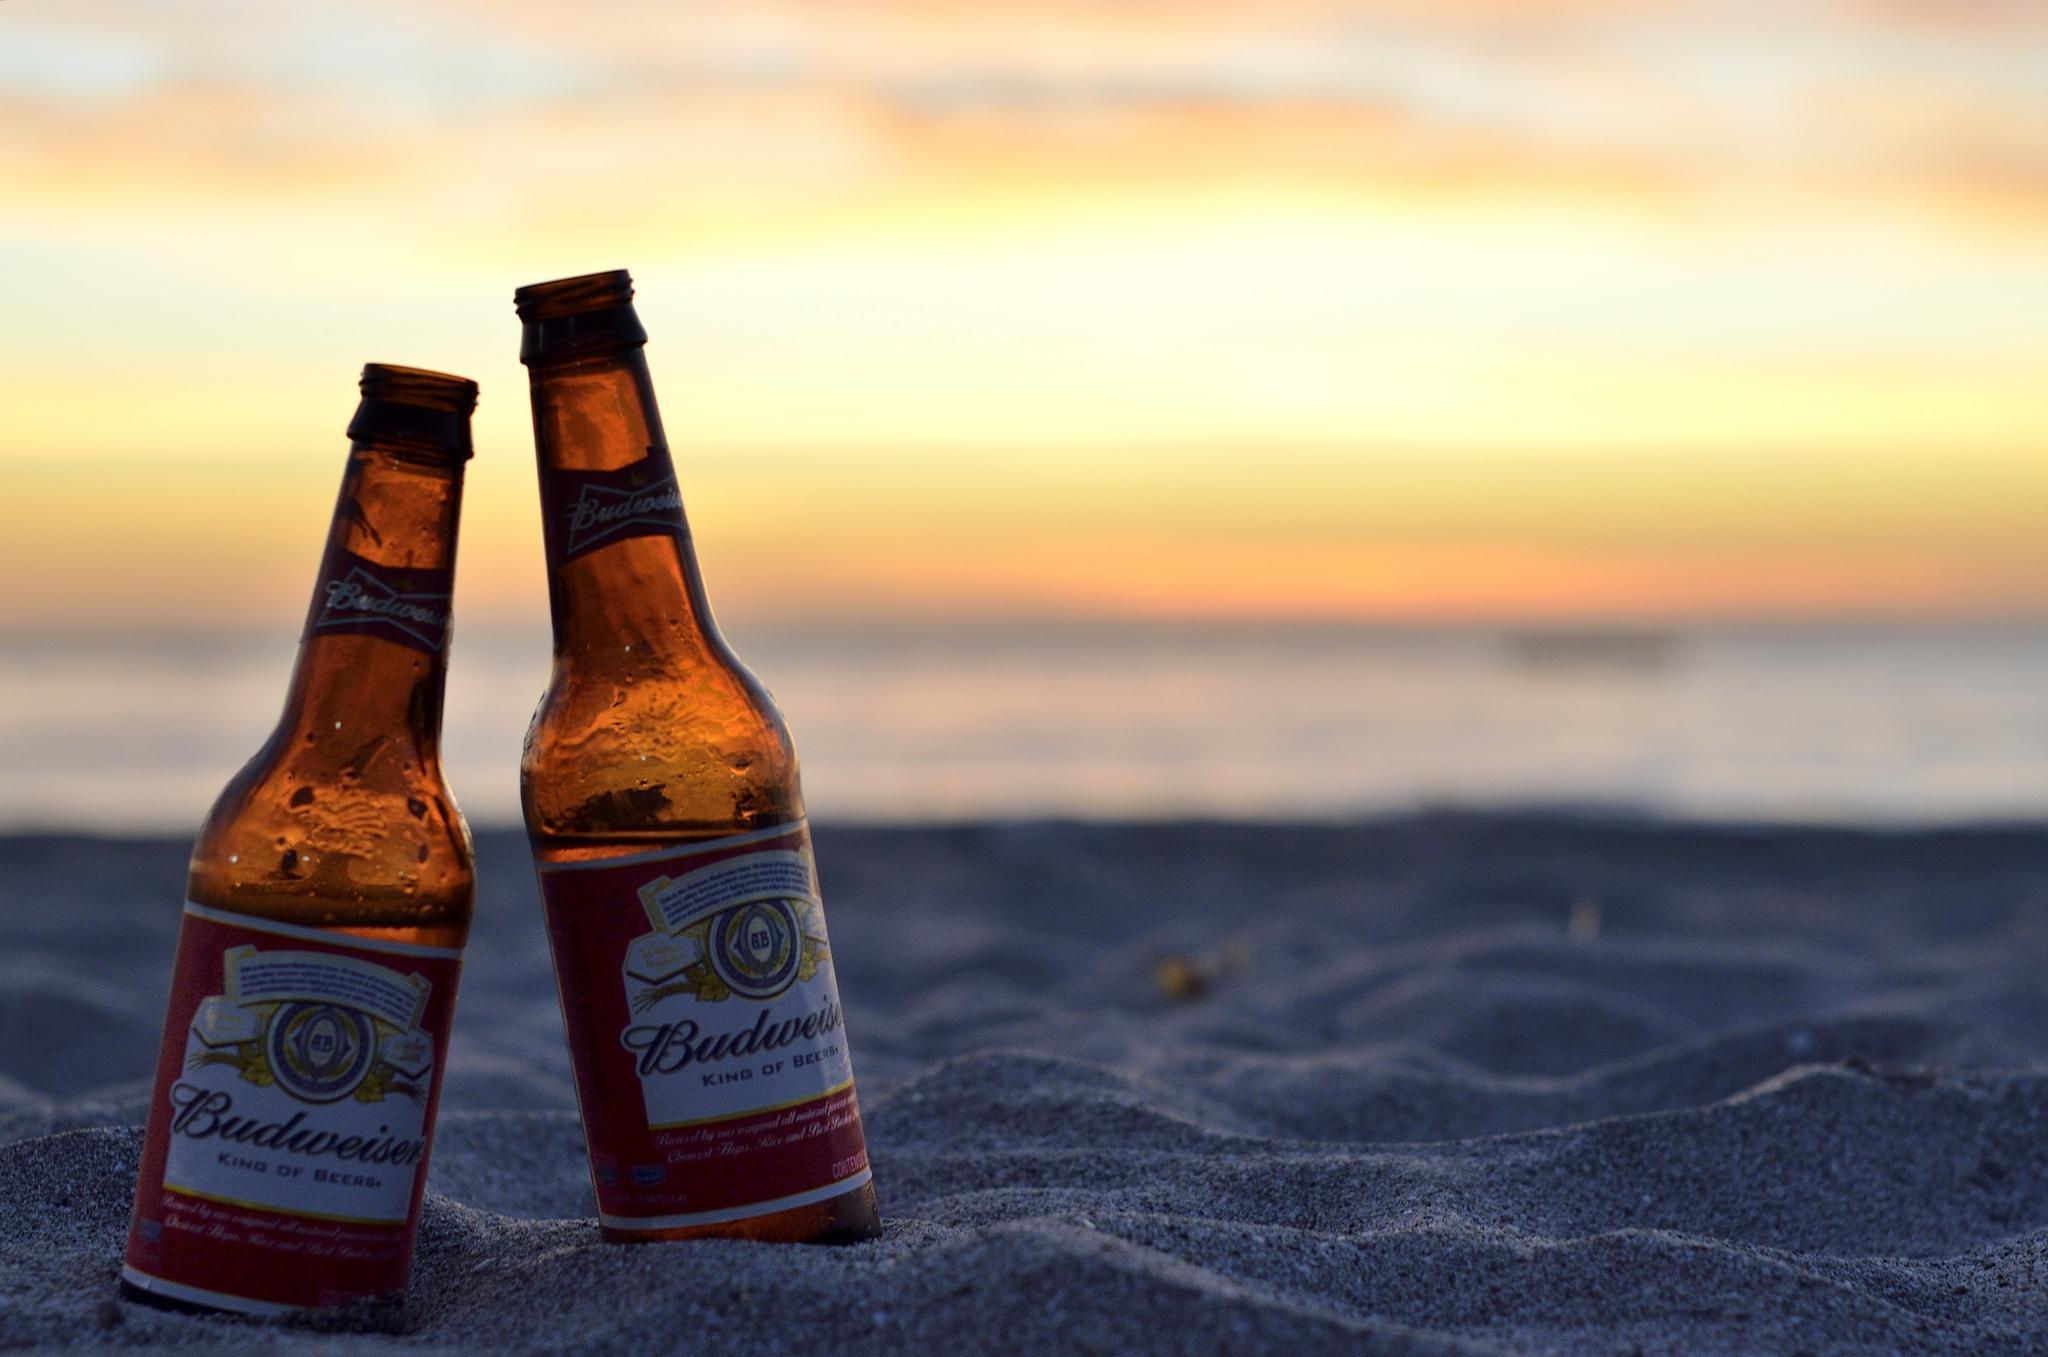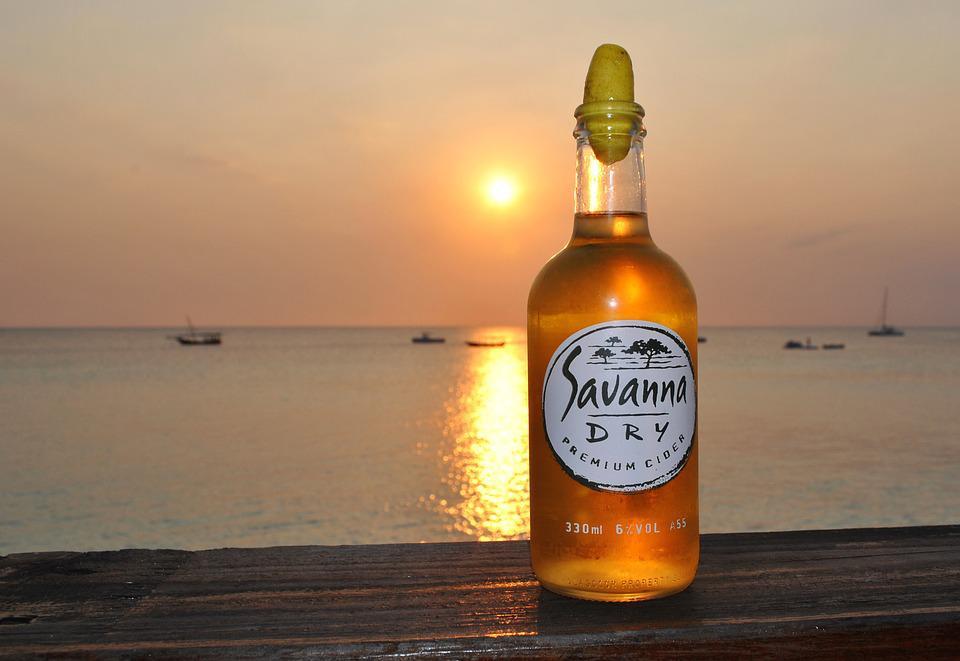The first image is the image on the left, the second image is the image on the right. Considering the images on both sides, is "All bottles have labels on the neck and the body." valid? Answer yes or no. No. The first image is the image on the left, the second image is the image on the right. Examine the images to the left and right. Is the description "One of the images shows exactly two bottles of beer." accurate? Answer yes or no. Yes. 